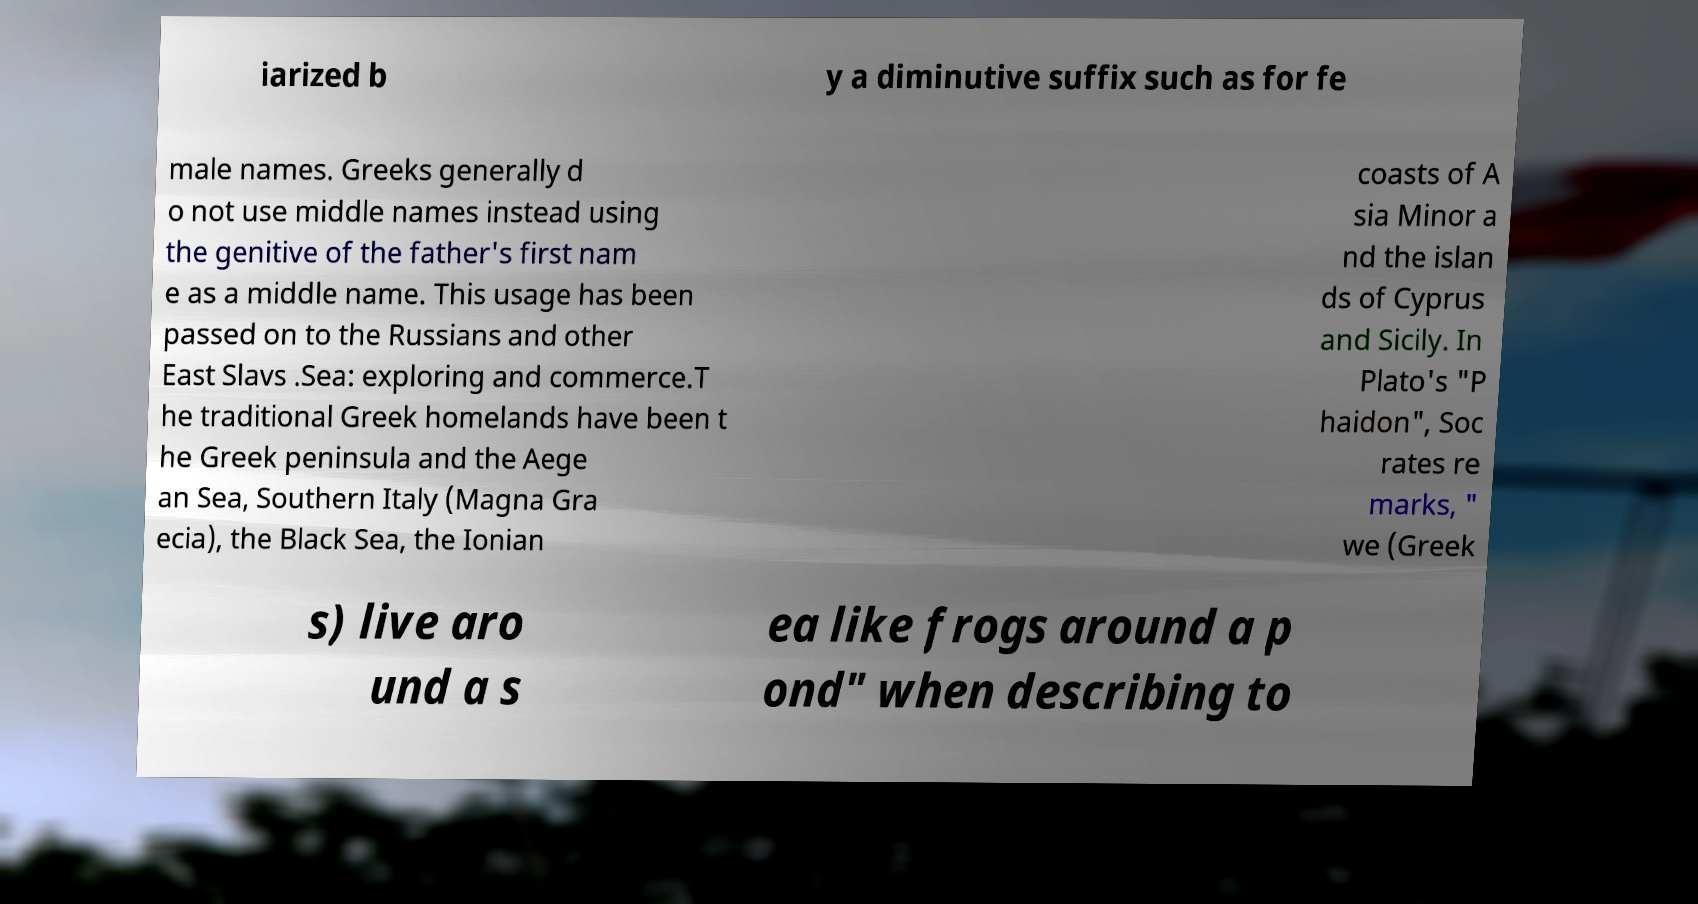Could you assist in decoding the text presented in this image and type it out clearly? iarized b y a diminutive suffix such as for fe male names. Greeks generally d o not use middle names instead using the genitive of the father's first nam e as a middle name. This usage has been passed on to the Russians and other East Slavs .Sea: exploring and commerce.T he traditional Greek homelands have been t he Greek peninsula and the Aege an Sea, Southern Italy (Magna Gra ecia), the Black Sea, the Ionian coasts of A sia Minor a nd the islan ds of Cyprus and Sicily. In Plato's "P haidon", Soc rates re marks, " we (Greek s) live aro und a s ea like frogs around a p ond" when describing to 